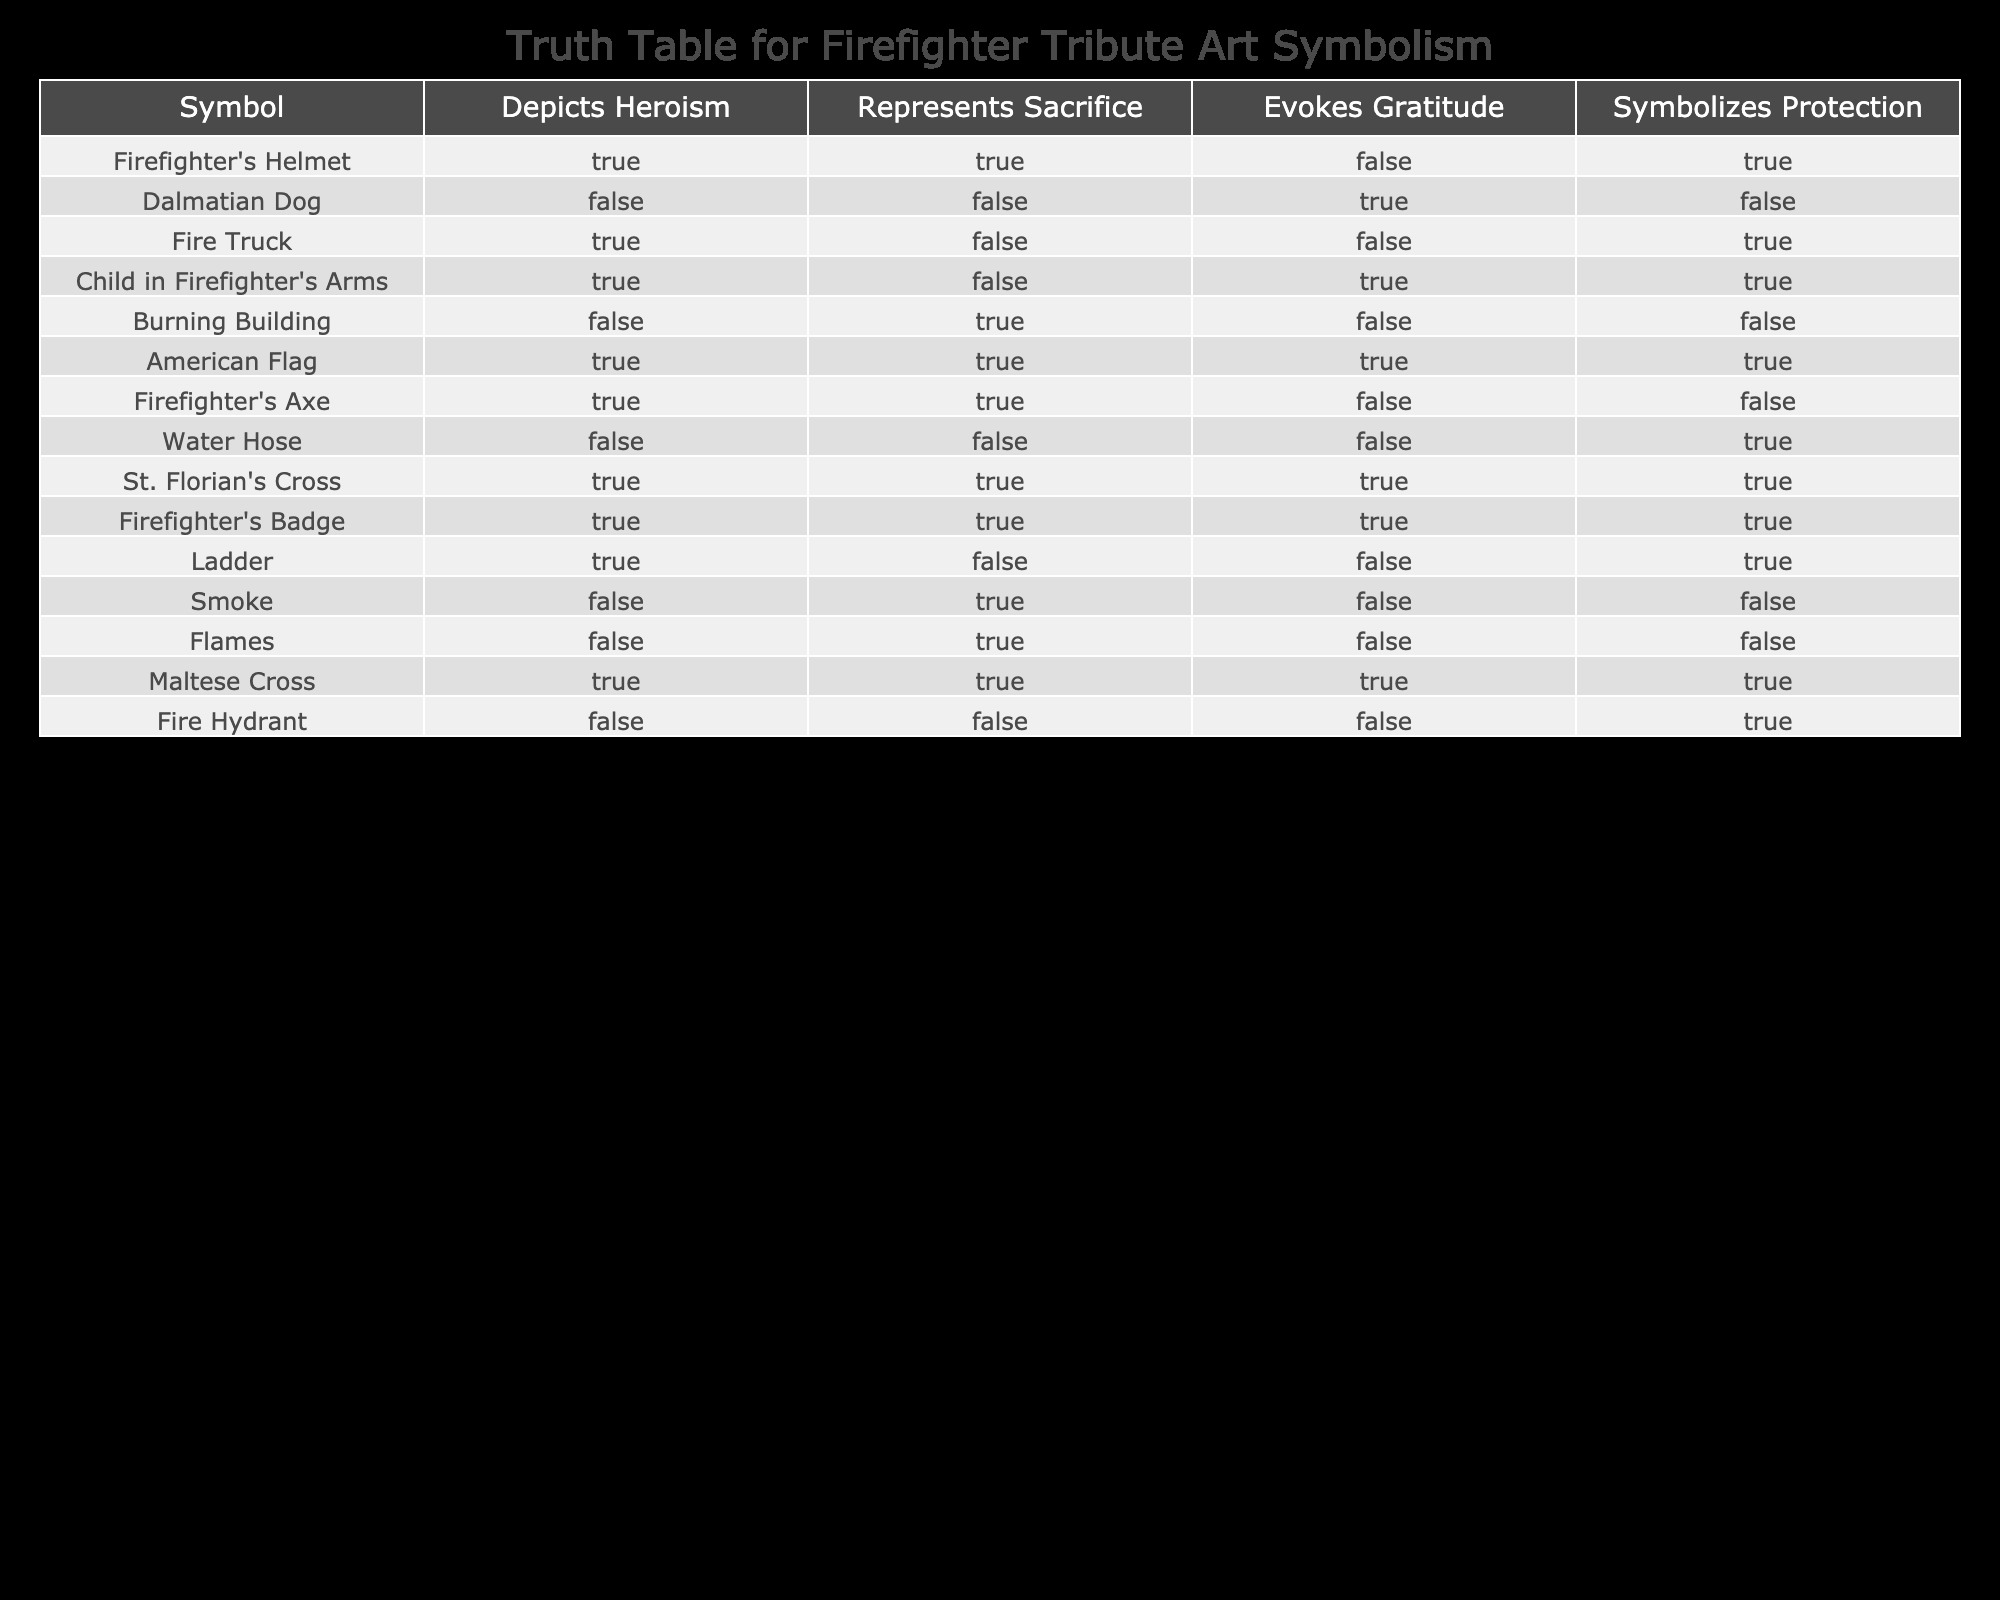What symbol in the table evokes gratitude? The Dalmatian Dog, Child in Firefighter's Arms, St. Florian's Cross, Firefighter's Badge, and Maltese Cross are symbols that evoke gratitude, as indicated by a "TRUE" value in the respective column.
Answer: Child in Firefighter's Arms, Dalmatian Dog, St. Florian's Cross, Firefighter's Badge, Maltese Cross Which symbols depict heroism but do not represent sacrifice? The Fire Truck, Ladder, and Maltese Cross depict heroism (marked "TRUE") and have "FALSE" for representing sacrifice. This is obtained by checking each symbol against the columns given.
Answer: Fire Truck, Ladder, Maltese Cross Does the American Flag evoke gratitude? The American Flag is listed with "TRUE" under the Evokes Gratitude column, indicating that it does evoke gratitude. This is a straightforward retrieval from the table.
Answer: Yes How many symbols symbolize protection? To find the number of symbols symbolizing protection, we need to count those with "TRUE" in the Symbolizes Protection column. The Firefighter's Helmet, Fire Truck, Child in Firefighter's Arms, Water Hose, Firefighter's Badge, and Fire Hydrant all check as "TRUE", totaling 6.
Answer: 6 Which symbol represents both sacrifice and protection? The only symbol that represents both sacrifice and protection is the Firefighter's Helmet, as indicated by "TRUE" in both columns. This is determined by looking for overlaps in the True values of those specific columns.
Answer: Firefighter's Helmet What is the total number of symbols that depict heroism? To find this total, we count the "TRUE" values in the Depicts Heroism column. The symbols with "TRUE" are the Firefighter's Helmet, Fire Truck, Child in Firefighter's Arms, American Flag, Firefighter's Axe, Ladder, St. Florian's Cross, Firefighter's Badge, and Maltese Cross, summing to 9.
Answer: 9 Do any symbols indicate both sacrifice and gratitude? The Firefighter's Badge, St. Florian's Cross, and American Flag indicate both sacrifice and gratitude, as they are marked "TRUE" in both relevant columns. Finding these involves checking the intersection of the columns.
Answer: Yes How many symbols do not depict heroism? The symbols that do not depict heroism are the Dalmatian Dog, Burning Building, Smoke, Flames, Fire Hydrant, and Water Hose, making it a total of 6 symbols that have "FALSE" for heroism.
Answer: 6 